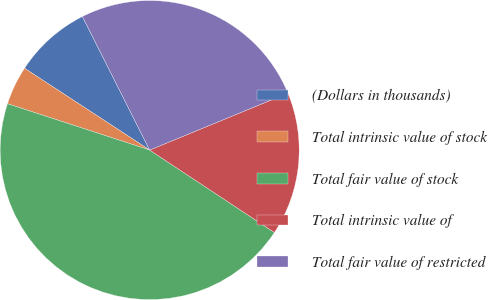Convert chart to OTSL. <chart><loc_0><loc_0><loc_500><loc_500><pie_chart><fcel>(Dollars in thousands)<fcel>Total intrinsic value of stock<fcel>Total fair value of stock<fcel>Total intrinsic value of<fcel>Total fair value of restricted<nl><fcel>8.36%<fcel>4.2%<fcel>45.72%<fcel>15.51%<fcel>26.21%<nl></chart> 